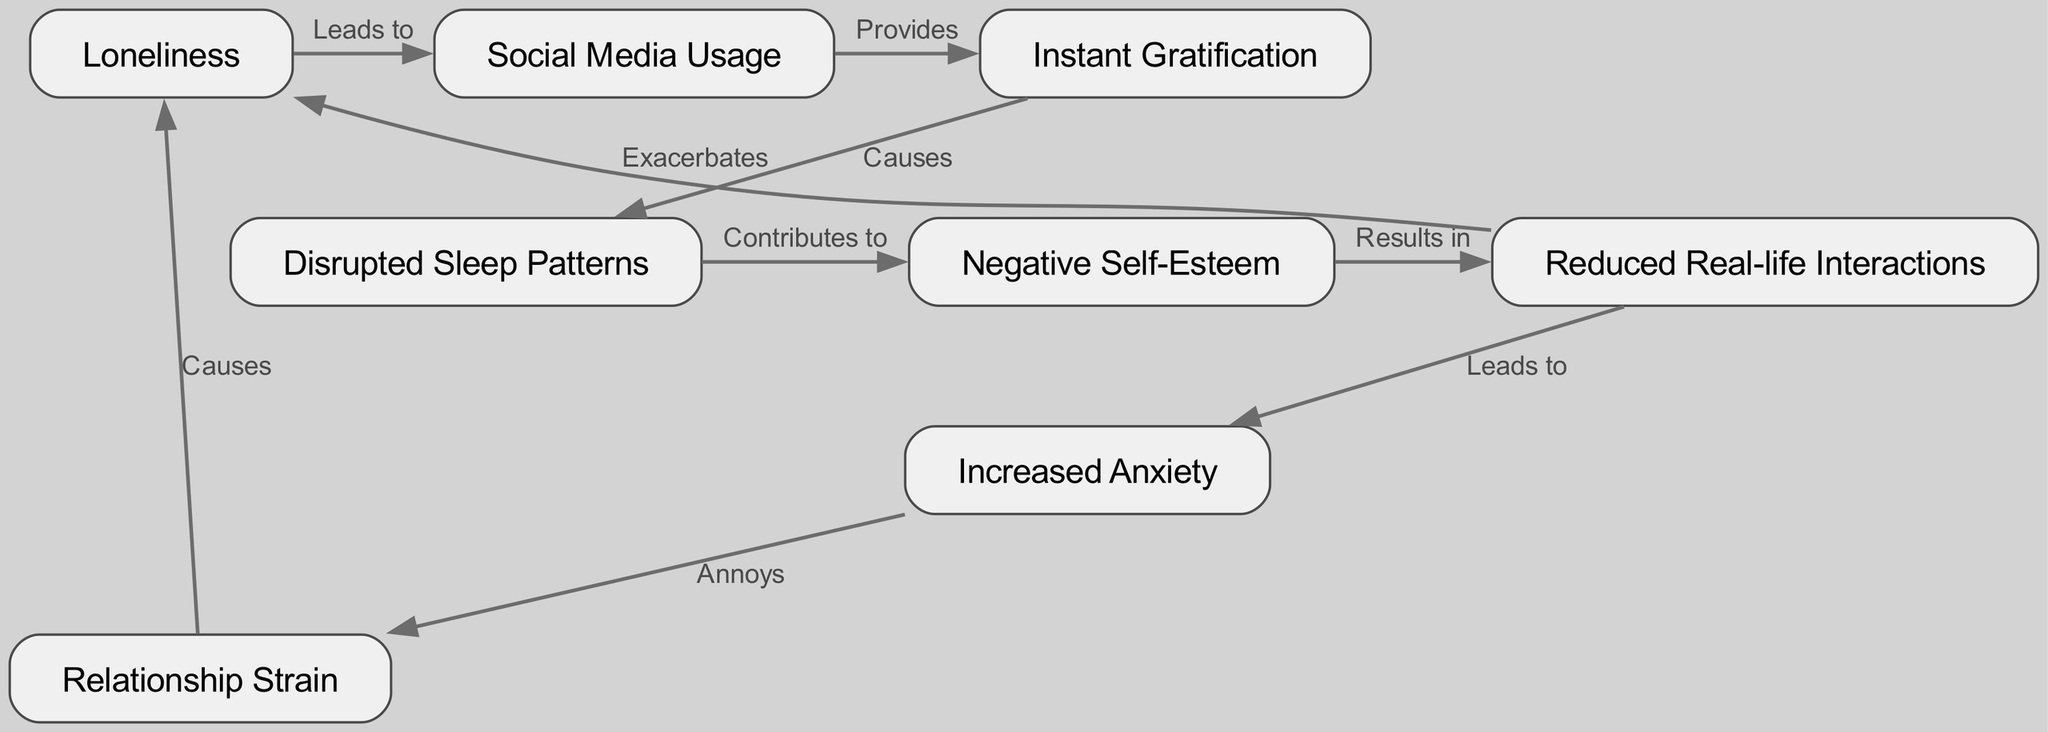What is the first node in the cycle? The first node is labeled "Loneliness," which is where the cycle starts according to the diagram.
Answer: Loneliness How many nodes are in the diagram? The diagram contains a total of eight distinct nodes representing different elements in the cycle of social media addiction.
Answer: Eight What relationship does "Social Media Usage" have with "Instant Gratification"? "Social Media Usage" leads to "Instant Gratification," indicating that increased use of social media results in the feeling of instant rewards.
Answer: Leads to Which node is connected to "Increased Anxiety"? "Increased Anxiety" is connected to and follows from "Reduced Real-life Interactions," showing a progression from social isolation to anxiety.
Answer: Reduced Real-life Interactions What is the consequence of "Disrupted Sleep Patterns"? "Disrupted Sleep Patterns" contributes to "Negative Self-Esteem," indicating that poor sleep can negatively affect self-worth.
Answer: Contributes to How does "Reduced Real-life Interactions" affect "Loneliness"? "Reduced Real-life Interactions" exacerbates "Loneliness," suggesting that less time spent with others increases feelings of loneliness.
Answer: Exacerbates What is the final consequence in the cycle? The final consequence in the cycle is "Causes," indicating that the effects loop back into the feeling of loneliness, completing the cycle.
Answer: Causes Which node represents the feeling of isolation? The node that represents the feeling of isolation is "Loneliness," which is the starting point of the cycle.
Answer: Loneliness What causes "Instant Gratification"? "Instant Gratification" is caused by "Social Media Usage," showing that the use of social media provides immediate rewards or feedback.
Answer: Causes 